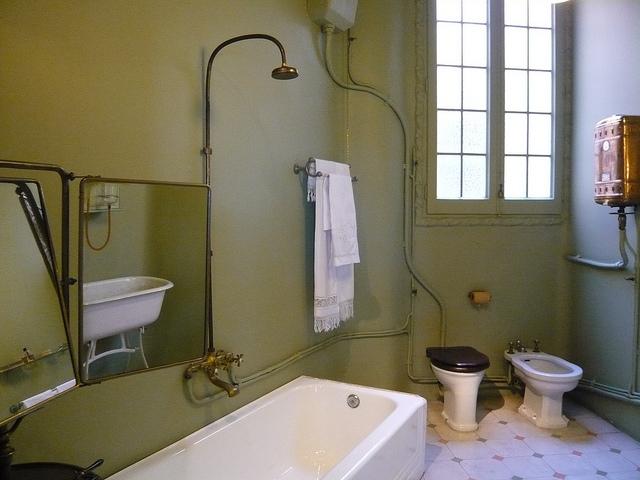Is this a modern bathroom?
Be succinct. No. Is there toilet paper?
Be succinct. Yes. What can you see the reflection of in the mirror?
Concise answer only. Tub. What is the thing next to the toilet called?
Concise answer only. Bidet. Is there a bathtub shown in the picture?
Short answer required. Yes. How do you know more than one person uses this bathroom?
Write a very short answer. 2 toilets. 